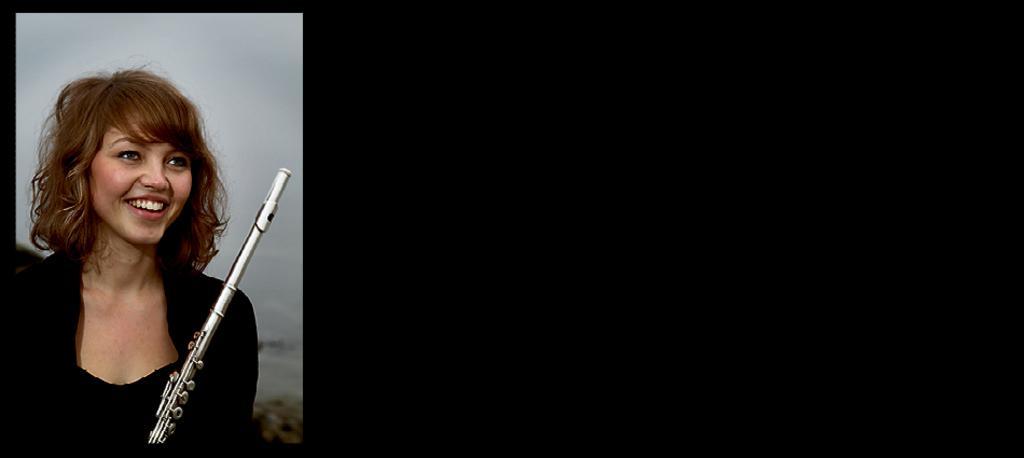Can you describe this image briefly? In this image I can see a woman who is wearing a black color dress, holding a musical instrument in her hand and smiling. 